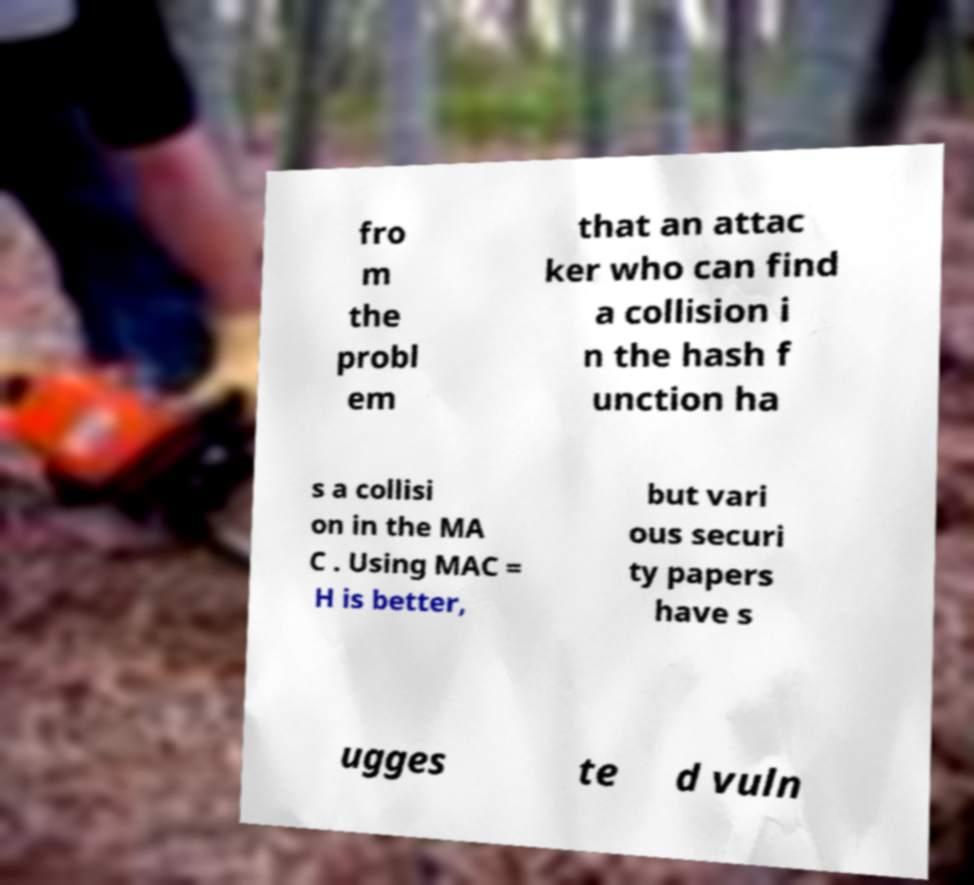Can you accurately transcribe the text from the provided image for me? fro m the probl em that an attac ker who can find a collision i n the hash f unction ha s a collisi on in the MA C . Using MAC = H is better, but vari ous securi ty papers have s ugges te d vuln 